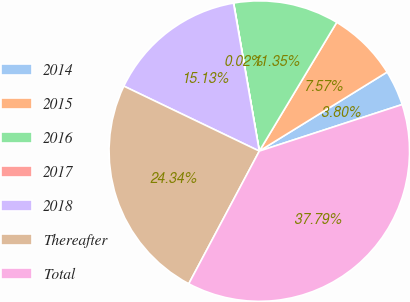Convert chart to OTSL. <chart><loc_0><loc_0><loc_500><loc_500><pie_chart><fcel>2014<fcel>2015<fcel>2016<fcel>2017<fcel>2018<fcel>Thereafter<fcel>Total<nl><fcel>3.8%<fcel>7.57%<fcel>11.35%<fcel>0.02%<fcel>15.13%<fcel>24.34%<fcel>37.79%<nl></chart> 